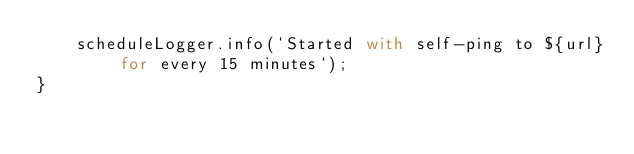<code> <loc_0><loc_0><loc_500><loc_500><_JavaScript_>    scheduleLogger.info(`Started with self-ping to ${url} for every 15 minutes`);
}
</code> 